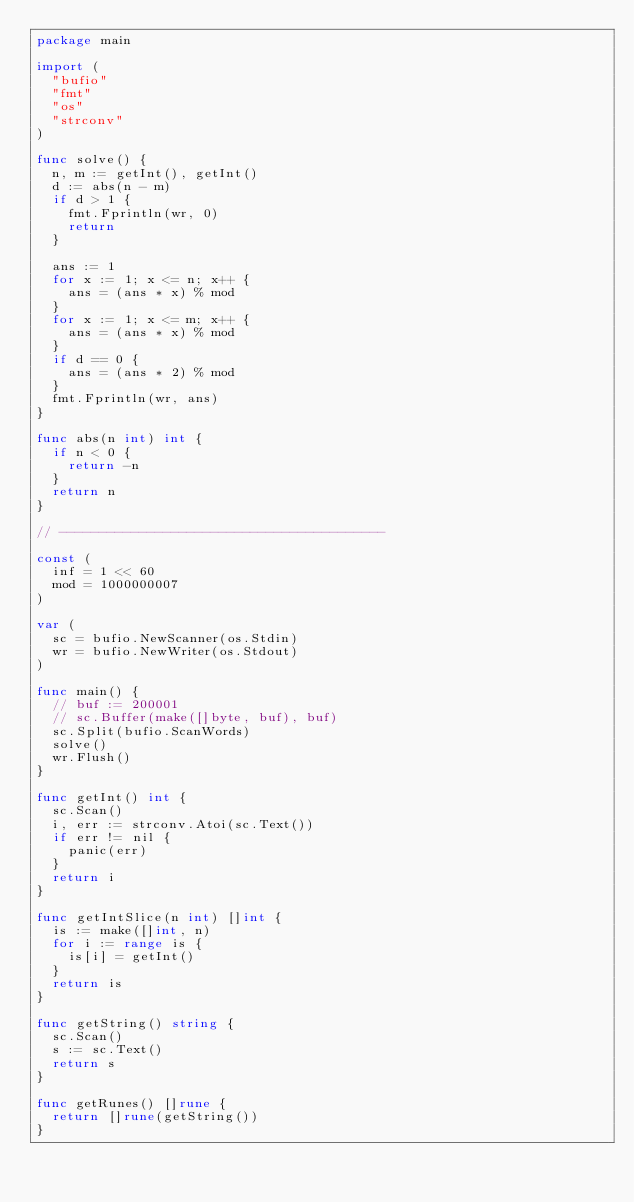<code> <loc_0><loc_0><loc_500><loc_500><_Go_>package main

import (
	"bufio"
	"fmt"
	"os"
	"strconv"
)

func solve() {
	n, m := getInt(), getInt()
	d := abs(n - m)
	if d > 1 {
		fmt.Fprintln(wr, 0)
		return
	}

	ans := 1
	for x := 1; x <= n; x++ {
		ans = (ans * x) % mod
	}
	for x := 1; x <= m; x++ {
		ans = (ans * x) % mod
	}
	if d == 0 {
		ans = (ans * 2) % mod
	}
	fmt.Fprintln(wr, ans)
}

func abs(n int) int {
	if n < 0 {
		return -n
	}
	return n
}

// -----------------------------------------

const (
	inf = 1 << 60
	mod = 1000000007
)

var (
	sc = bufio.NewScanner(os.Stdin)
	wr = bufio.NewWriter(os.Stdout)
)

func main() {
	// buf := 200001
	// sc.Buffer(make([]byte, buf), buf)
	sc.Split(bufio.ScanWords)
	solve()
	wr.Flush()
}

func getInt() int {
	sc.Scan()
	i, err := strconv.Atoi(sc.Text())
	if err != nil {
		panic(err)
	}
	return i
}

func getIntSlice(n int) []int {
	is := make([]int, n)
	for i := range is {
		is[i] = getInt()
	}
	return is
}

func getString() string {
	sc.Scan()
	s := sc.Text()
	return s
}

func getRunes() []rune {
	return []rune(getString())
}
</code> 